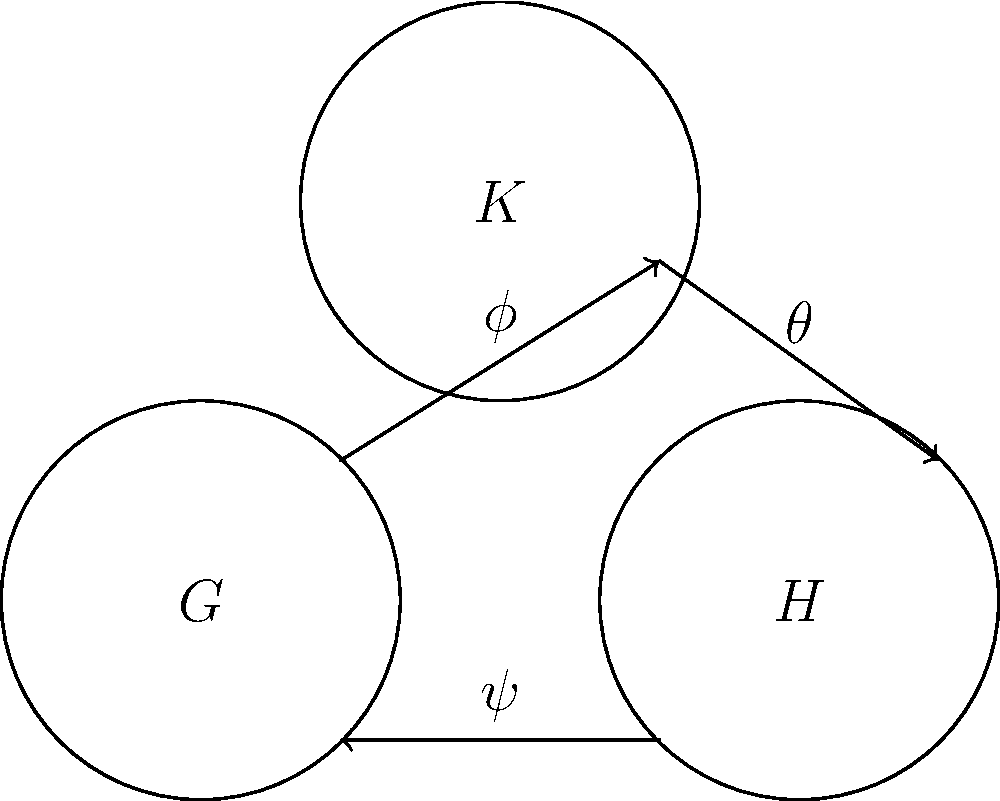Consider the diagram depicting homomorphisms between three group structures $G$, $H$, and $K$. Given that $\phi: G \to K$, $\psi: H \to G$, and $\theta: K \to H$ are group homomorphisms, determine whether the composition $\theta \circ \phi \circ \psi$ is necessarily a group homomorphism from $H$ to $H$. If it is, explain why. If not, provide a counterexample. Let's approach this step-by-step:

1) First, recall that the composition of group homomorphisms is also a group homomorphism. This is a fundamental property in group theory.

2) Let's break down the composition $\theta \circ \phi \circ \psi$:
   - $\psi: H \to G$
   - $\phi: G \to K$
   - $\theta: K \to H$

3) The composition is well-defined because:
   - $\psi$ maps from $H$ to $G$
   - $\phi$ maps from $G$ to $K$
   - $\theta$ maps from $K$ to $H$

4) Therefore, $\theta \circ \phi \circ \psi$ maps from $H$ to $H$.

5) Since each of $\theta$, $\phi$, and $\psi$ is a group homomorphism, and the composition of group homomorphisms is a group homomorphism, we can conclude that $\theta \circ \phi \circ \psi$ is indeed a group homomorphism from $H$ to $H$.

6) To prove this formally, let $a, b \in H$. Then:

   $(\theta \circ \phi \circ \psi)(ab) = \theta(\phi(\psi(ab)))$
                                       $= \theta(\phi(\psi(a)\psi(b)))$  (since $\psi$ is a homomorphism)
                                       $= \theta(\phi(\psi(a))\phi(\psi(b)))$  (since $\phi$ is a homomorphism)
                                       $= \theta(\phi(\psi(a)))\theta(\phi(\psi(b)))$  (since $\theta$ is a homomorphism)
                                       $= (\theta \circ \phi \circ \psi)(a)(\theta \circ \phi \circ \psi)(b)$

This proves that $\theta \circ \phi \circ \psi$ preserves the group operation, and is thus a group homomorphism.
Answer: Yes, $\theta \circ \phi \circ \psi$ is a group homomorphism from $H$ to $H$. 